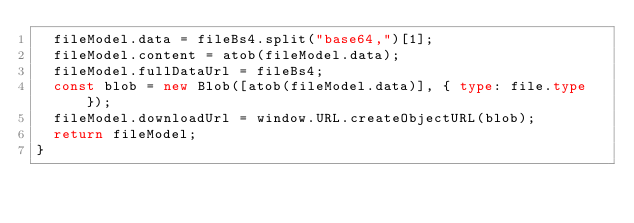<code> <loc_0><loc_0><loc_500><loc_500><_TypeScript_>  fileModel.data = fileBs4.split("base64,")[1];
  fileModel.content = atob(fileModel.data);
  fileModel.fullDataUrl = fileBs4;
  const blob = new Blob([atob(fileModel.data)], { type: file.type });
  fileModel.downloadUrl = window.URL.createObjectURL(blob);
  return fileModel;
}
</code> 